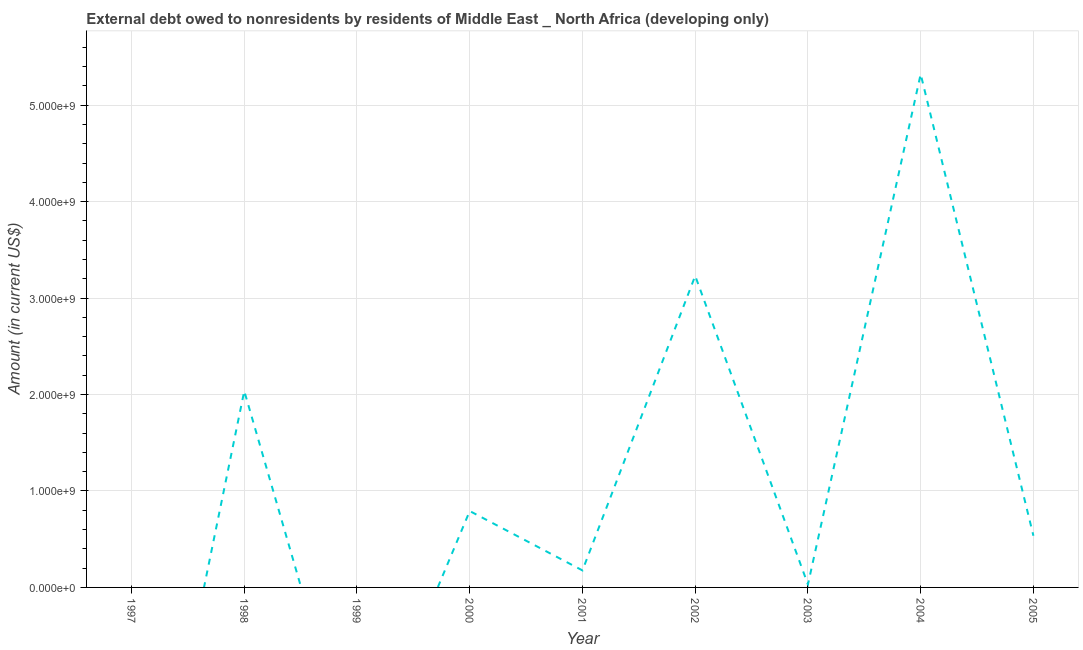What is the debt in 1998?
Your response must be concise. 2.04e+09. Across all years, what is the maximum debt?
Keep it short and to the point. 5.32e+09. Across all years, what is the minimum debt?
Give a very brief answer. 0. In which year was the debt maximum?
Your response must be concise. 2004. What is the sum of the debt?
Provide a succinct answer. 1.21e+1. What is the difference between the debt in 2001 and 2004?
Your answer should be compact. -5.14e+09. What is the average debt per year?
Provide a short and direct response. 1.35e+09. What is the median debt?
Provide a short and direct response. 5.36e+08. In how many years, is the debt greater than 5200000000 US$?
Ensure brevity in your answer.  1. What is the ratio of the debt in 2004 to that in 2005?
Your answer should be compact. 9.93. Is the debt in 2003 less than that in 2005?
Offer a terse response. Yes. Is the difference between the debt in 2002 and 2003 greater than the difference between any two years?
Your answer should be very brief. No. What is the difference between the highest and the second highest debt?
Your answer should be very brief. 2.09e+09. Is the sum of the debt in 1998 and 2001 greater than the maximum debt across all years?
Offer a very short reply. No. What is the difference between the highest and the lowest debt?
Offer a very short reply. 5.32e+09. How many lines are there?
Ensure brevity in your answer.  1. Are the values on the major ticks of Y-axis written in scientific E-notation?
Your answer should be compact. Yes. Does the graph contain any zero values?
Your answer should be very brief. Yes. Does the graph contain grids?
Your answer should be compact. Yes. What is the title of the graph?
Offer a terse response. External debt owed to nonresidents by residents of Middle East _ North Africa (developing only). What is the label or title of the X-axis?
Your answer should be very brief. Year. What is the Amount (in current US$) in 1997?
Ensure brevity in your answer.  0. What is the Amount (in current US$) of 1998?
Your answer should be very brief. 2.04e+09. What is the Amount (in current US$) in 1999?
Ensure brevity in your answer.  0. What is the Amount (in current US$) in 2000?
Offer a terse response. 7.92e+08. What is the Amount (in current US$) of 2001?
Offer a very short reply. 1.76e+08. What is the Amount (in current US$) in 2002?
Your response must be concise. 3.23e+09. What is the Amount (in current US$) of 2003?
Your answer should be very brief. 3.05e+07. What is the Amount (in current US$) of 2004?
Your answer should be very brief. 5.32e+09. What is the Amount (in current US$) in 2005?
Your answer should be compact. 5.36e+08. What is the difference between the Amount (in current US$) in 1998 and 2000?
Your response must be concise. 1.24e+09. What is the difference between the Amount (in current US$) in 1998 and 2001?
Ensure brevity in your answer.  1.86e+09. What is the difference between the Amount (in current US$) in 1998 and 2002?
Your answer should be compact. -1.19e+09. What is the difference between the Amount (in current US$) in 1998 and 2003?
Provide a short and direct response. 2.01e+09. What is the difference between the Amount (in current US$) in 1998 and 2004?
Your answer should be compact. -3.28e+09. What is the difference between the Amount (in current US$) in 1998 and 2005?
Ensure brevity in your answer.  1.50e+09. What is the difference between the Amount (in current US$) in 2000 and 2001?
Your response must be concise. 6.16e+08. What is the difference between the Amount (in current US$) in 2000 and 2002?
Offer a terse response. -2.44e+09. What is the difference between the Amount (in current US$) in 2000 and 2003?
Provide a short and direct response. 7.62e+08. What is the difference between the Amount (in current US$) in 2000 and 2004?
Keep it short and to the point. -4.53e+09. What is the difference between the Amount (in current US$) in 2000 and 2005?
Your answer should be compact. 2.56e+08. What is the difference between the Amount (in current US$) in 2001 and 2002?
Your response must be concise. -3.05e+09. What is the difference between the Amount (in current US$) in 2001 and 2003?
Provide a short and direct response. 1.46e+08. What is the difference between the Amount (in current US$) in 2001 and 2004?
Provide a short and direct response. -5.14e+09. What is the difference between the Amount (in current US$) in 2001 and 2005?
Offer a terse response. -3.59e+08. What is the difference between the Amount (in current US$) in 2002 and 2003?
Make the answer very short. 3.20e+09. What is the difference between the Amount (in current US$) in 2002 and 2004?
Ensure brevity in your answer.  -2.09e+09. What is the difference between the Amount (in current US$) in 2002 and 2005?
Ensure brevity in your answer.  2.69e+09. What is the difference between the Amount (in current US$) in 2003 and 2004?
Give a very brief answer. -5.29e+09. What is the difference between the Amount (in current US$) in 2003 and 2005?
Your answer should be very brief. -5.05e+08. What is the difference between the Amount (in current US$) in 2004 and 2005?
Your answer should be very brief. 4.79e+09. What is the ratio of the Amount (in current US$) in 1998 to that in 2000?
Your answer should be compact. 2.57. What is the ratio of the Amount (in current US$) in 1998 to that in 2001?
Offer a very short reply. 11.54. What is the ratio of the Amount (in current US$) in 1998 to that in 2002?
Offer a very short reply. 0.63. What is the ratio of the Amount (in current US$) in 1998 to that in 2003?
Your answer should be compact. 66.69. What is the ratio of the Amount (in current US$) in 1998 to that in 2004?
Ensure brevity in your answer.  0.38. What is the ratio of the Amount (in current US$) in 1998 to that in 2005?
Your answer should be very brief. 3.8. What is the ratio of the Amount (in current US$) in 2000 to that in 2001?
Your response must be concise. 4.49. What is the ratio of the Amount (in current US$) in 2000 to that in 2002?
Your response must be concise. 0.24. What is the ratio of the Amount (in current US$) in 2000 to that in 2003?
Give a very brief answer. 25.94. What is the ratio of the Amount (in current US$) in 2000 to that in 2004?
Offer a very short reply. 0.15. What is the ratio of the Amount (in current US$) in 2000 to that in 2005?
Keep it short and to the point. 1.48. What is the ratio of the Amount (in current US$) in 2001 to that in 2002?
Provide a short and direct response. 0.06. What is the ratio of the Amount (in current US$) in 2001 to that in 2003?
Provide a succinct answer. 5.78. What is the ratio of the Amount (in current US$) in 2001 to that in 2004?
Your response must be concise. 0.03. What is the ratio of the Amount (in current US$) in 2001 to that in 2005?
Keep it short and to the point. 0.33. What is the ratio of the Amount (in current US$) in 2002 to that in 2003?
Keep it short and to the point. 105.79. What is the ratio of the Amount (in current US$) in 2002 to that in 2004?
Your response must be concise. 0.61. What is the ratio of the Amount (in current US$) in 2002 to that in 2005?
Your answer should be compact. 6.03. What is the ratio of the Amount (in current US$) in 2003 to that in 2004?
Make the answer very short. 0.01. What is the ratio of the Amount (in current US$) in 2003 to that in 2005?
Keep it short and to the point. 0.06. What is the ratio of the Amount (in current US$) in 2004 to that in 2005?
Keep it short and to the point. 9.93. 